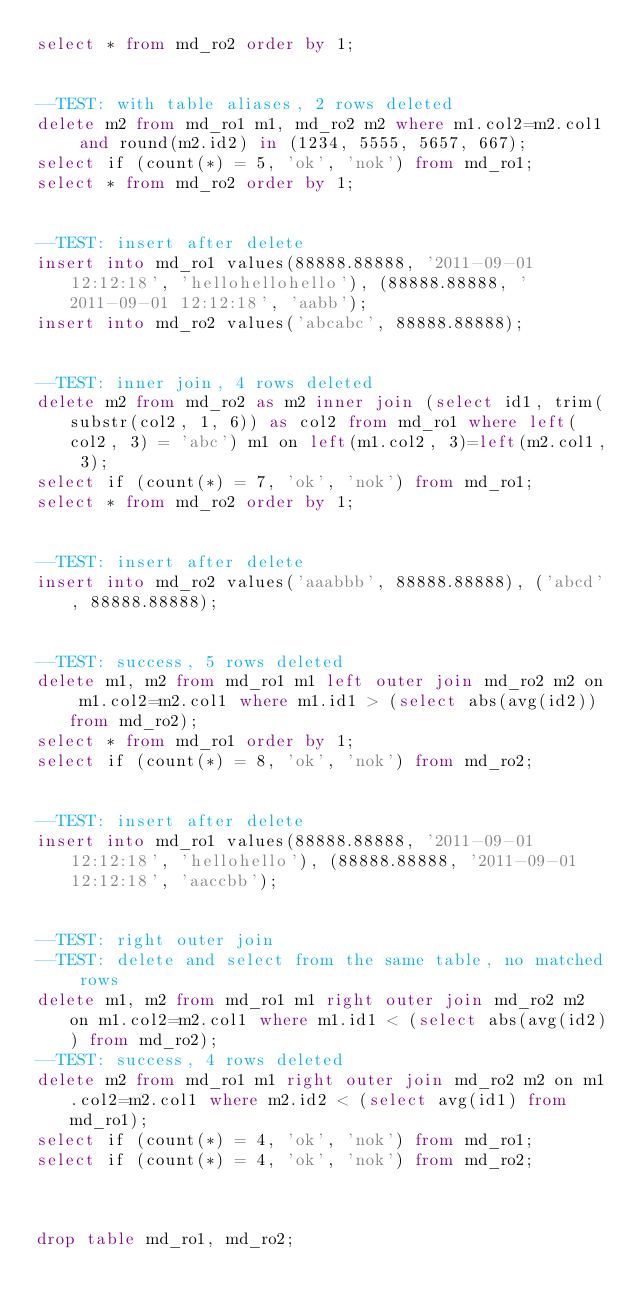<code> <loc_0><loc_0><loc_500><loc_500><_SQL_>select * from md_ro2 order by 1;


--TEST: with table aliases, 2 rows deleted
delete m2 from md_ro1 m1, md_ro2 m2 where m1.col2=m2.col1 and round(m2.id2) in (1234, 5555, 5657, 667);
select if (count(*) = 5, 'ok', 'nok') from md_ro1;
select * from md_ro2 order by 1;


--TEST: insert after delete
insert into md_ro1 values(88888.88888, '2011-09-01 12:12:18', 'hellohellohello'), (88888.88888, '2011-09-01 12:12:18', 'aabb');
insert into md_ro2 values('abcabc', 88888.88888);


--TEST: inner join, 4 rows deleted
delete m2 from md_ro2 as m2 inner join (select id1, trim(substr(col2, 1, 6)) as col2 from md_ro1 where left(col2, 3) = 'abc') m1 on left(m1.col2, 3)=left(m2.col1, 3);
select if (count(*) = 7, 'ok', 'nok') from md_ro1;
select * from md_ro2 order by 1;


--TEST: insert after delete
insert into md_ro2 values('aaabbb', 88888.88888), ('abcd', 88888.88888);


--TEST: success, 5 rows deleted
delete m1, m2 from md_ro1 m1 left outer join md_ro2 m2 on m1.col2=m2.col1 where m1.id1 > (select abs(avg(id2)) from md_ro2);
select * from md_ro1 order by 1;
select if (count(*) = 8, 'ok', 'nok') from md_ro2;


--TEST: insert after delete
insert into md_ro1 values(88888.88888, '2011-09-01 12:12:18', 'hellohello'), (88888.88888, '2011-09-01 12:12:18', 'aaccbb');


--TEST: right outer join
--TEST: delete and select from the same table, no matched rows
delete m1, m2 from md_ro1 m1 right outer join md_ro2 m2 on m1.col2=m2.col1 where m1.id1 < (select abs(avg(id2)) from md_ro2);
--TEST: success, 4 rows deleted
delete m2 from md_ro1 m1 right outer join md_ro2 m2 on m1.col2=m2.col1 where m2.id2 < (select avg(id1) from md_ro1);
select if (count(*) = 4, 'ok', 'nok') from md_ro1;
select if (count(*) = 4, 'ok', 'nok') from md_ro2;



drop table md_ro1, md_ro2;






</code> 